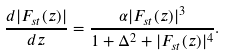Convert formula to latex. <formula><loc_0><loc_0><loc_500><loc_500>\frac { d | F _ { s t } ( z ) | } { d z } = \frac { \alpha | F _ { s t } ( z ) | ^ { 3 } } { 1 + \Delta ^ { 2 } + | F _ { s t } ( z ) | ^ { 4 } } .</formula> 